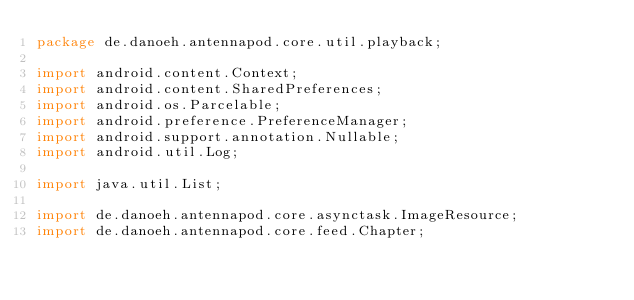Convert code to text. <code><loc_0><loc_0><loc_500><loc_500><_Java_>package de.danoeh.antennapod.core.util.playback;

import android.content.Context;
import android.content.SharedPreferences;
import android.os.Parcelable;
import android.preference.PreferenceManager;
import android.support.annotation.Nullable;
import android.util.Log;

import java.util.List;

import de.danoeh.antennapod.core.asynctask.ImageResource;
import de.danoeh.antennapod.core.feed.Chapter;</code> 